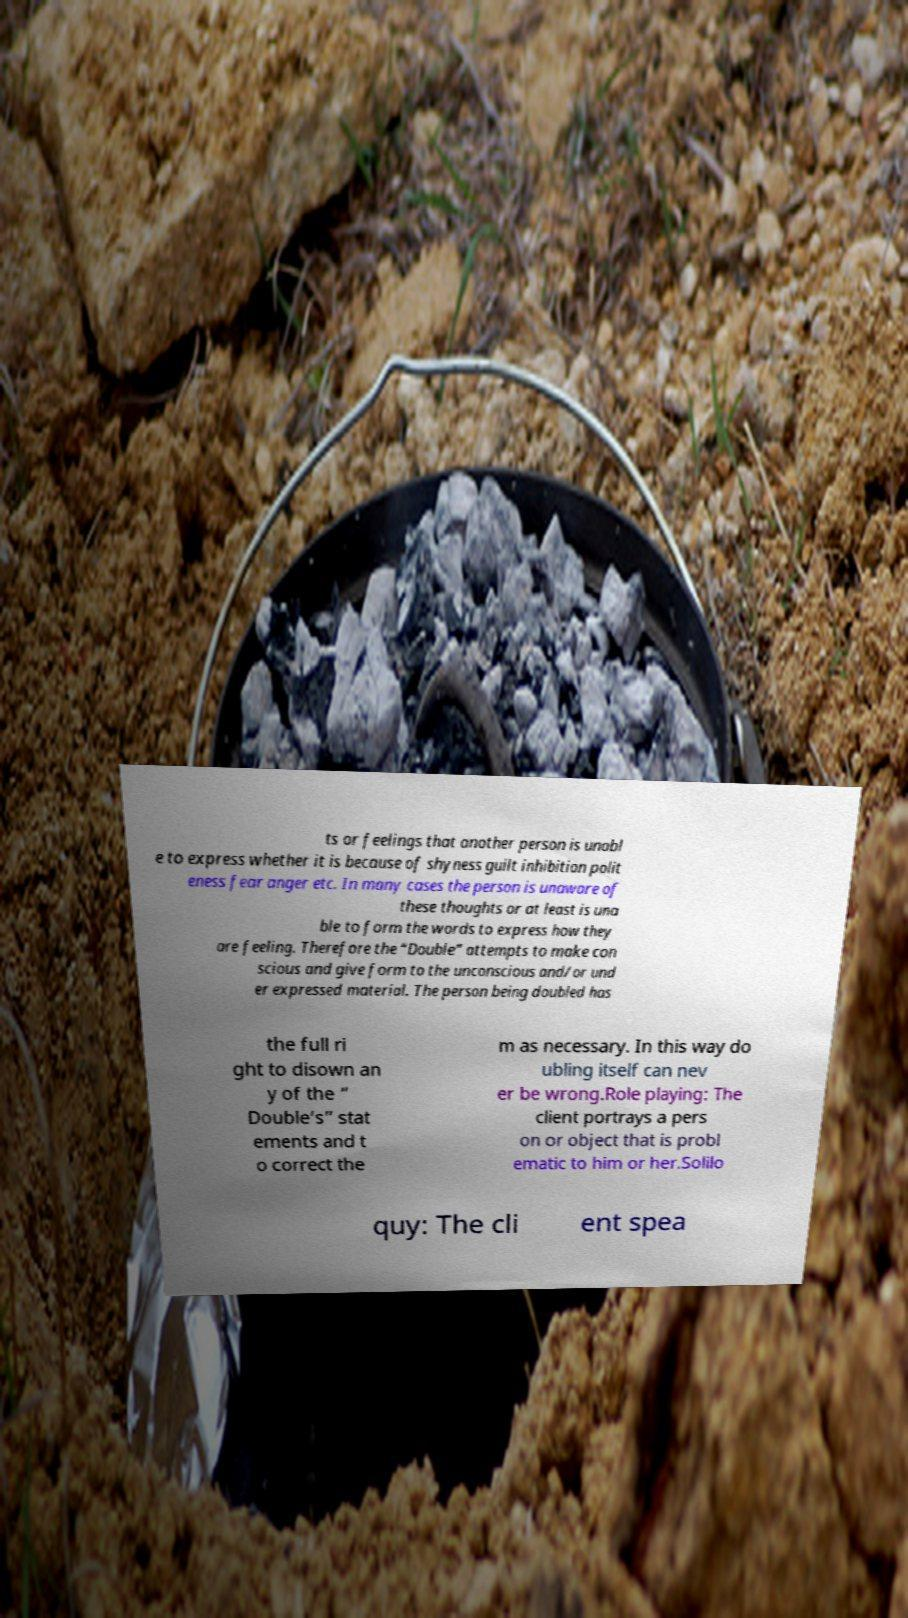Can you accurately transcribe the text from the provided image for me? ts or feelings that another person is unabl e to express whether it is because of shyness guilt inhibition polit eness fear anger etc. In many cases the person is unaware of these thoughts or at least is una ble to form the words to express how they are feeling. Therefore the “Double” attempts to make con scious and give form to the unconscious and/or und er expressed material. The person being doubled has the full ri ght to disown an y of the “ Double’s” stat ements and t o correct the m as necessary. In this way do ubling itself can nev er be wrong.Role playing: The client portrays a pers on or object that is probl ematic to him or her.Solilo quy: The cli ent spea 